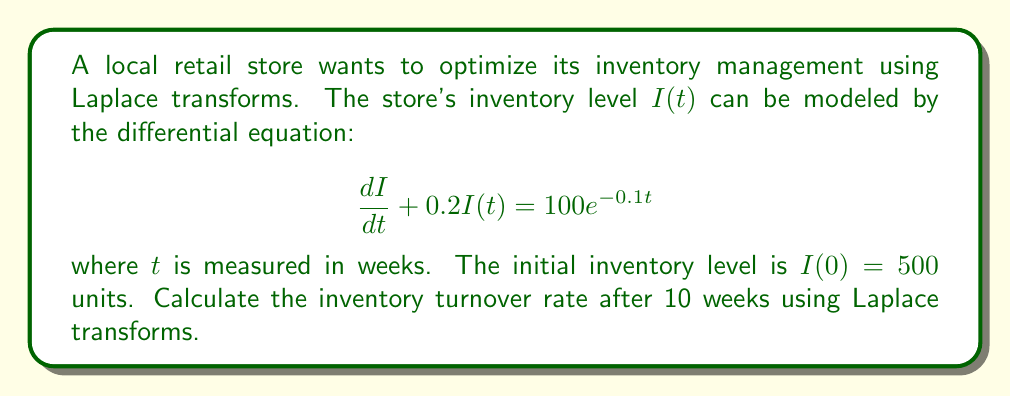Give your solution to this math problem. To solve this problem using Laplace transforms, we'll follow these steps:

1) First, let's take the Laplace transform of both sides of the differential equation:
   $$\mathcal{L}\left\{\frac{dI}{dt} + 0.2I(t)\right\} = \mathcal{L}\{100e^{-0.1t}\}$$

2) Using Laplace transform properties:
   $$s\mathcal{L}\{I(t)\} - I(0) + 0.2\mathcal{L}\{I(t)\} = \frac{100}{s+0.1}$$

3) Let $\mathcal{L}\{I(t)\} = F(s)$. Substituting $I(0) = 500$:
   $$sF(s) - 500 + 0.2F(s) = \frac{100}{s+0.1}$$

4) Solving for $F(s)$:
   $$F(s) = \frac{500}{s+0.2} + \frac{100}{(s+0.2)(s+0.1)}$$

5) Using partial fraction decomposition:
   $$F(s) = \frac{500}{s+0.2} + \frac{1000}{s+0.2} - \frac{1000}{s+0.1}$$

6) Taking the inverse Laplace transform:
   $$I(t) = 1500e^{-0.2t} - 1000e^{-0.1t}$$

7) To find the inventory level at 10 weeks:
   $$I(10) = 1500e^{-0.2(10)} - 1000e^{-0.1(10)} \approx 247.89$$

8) The inventory turnover rate is calculated as:
   $$\text{Turnover Rate} = \frac{\text{Initial Inventory} - \text{Final Inventory}}{\text{Initial Inventory}}$$

   $$\text{Turnover Rate} = \frac{500 - 247.89}{500} \approx 0.5042$$

Therefore, the inventory turnover rate after 10 weeks is approximately 0.5042 or 50.42%.
Answer: The inventory turnover rate after 10 weeks is approximately 0.5042 or 50.42%. 